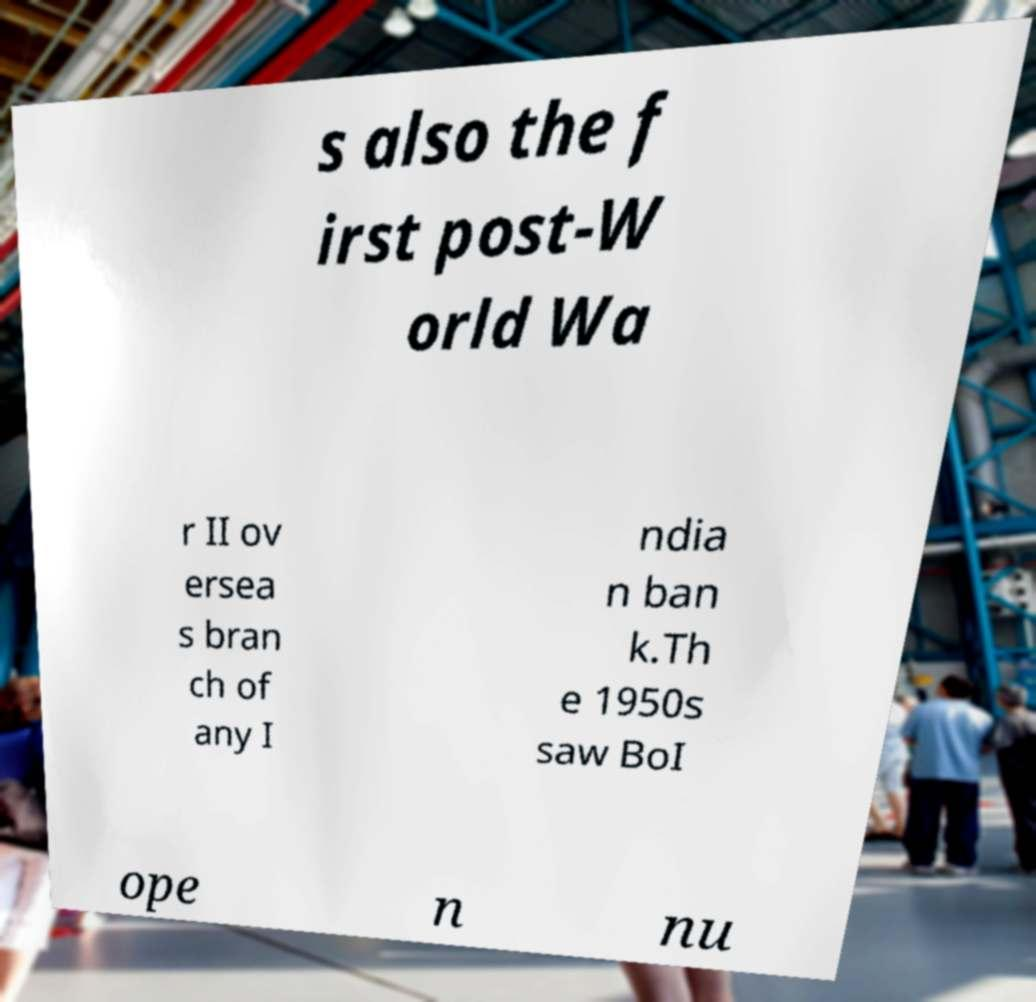Please identify and transcribe the text found in this image. s also the f irst post-W orld Wa r II ov ersea s bran ch of any I ndia n ban k.Th e 1950s saw BoI ope n nu 